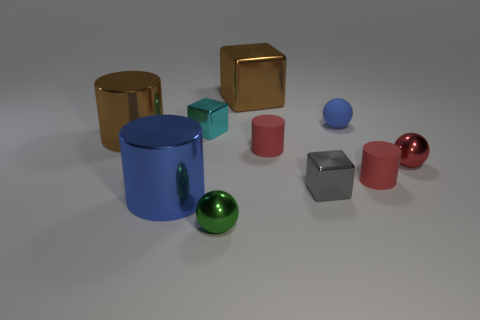Subtract all balls. How many objects are left? 7 Subtract all red objects. Subtract all blue things. How many objects are left? 5 Add 3 small blue things. How many small blue things are left? 4 Add 6 small cylinders. How many small cylinders exist? 8 Subtract 0 yellow spheres. How many objects are left? 10 